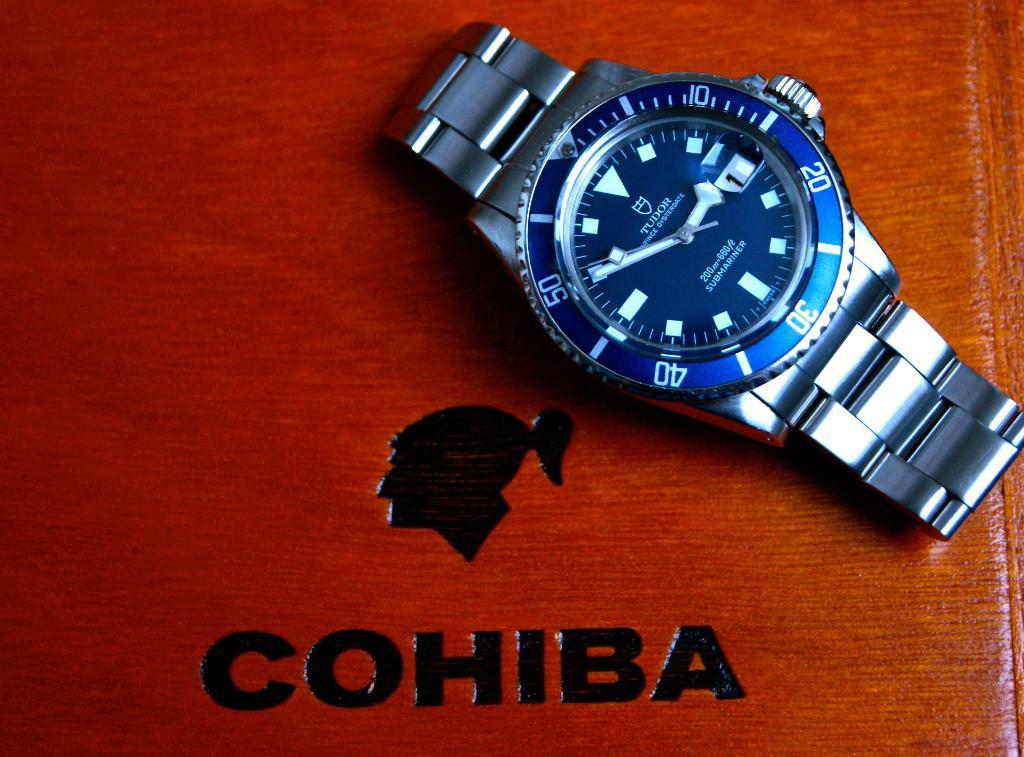<image>
Write a terse but informative summary of the picture. A nice Tudor watch with a stainless steel watchband and cobalt blue watch face sitting on a wood Cohiba box. 